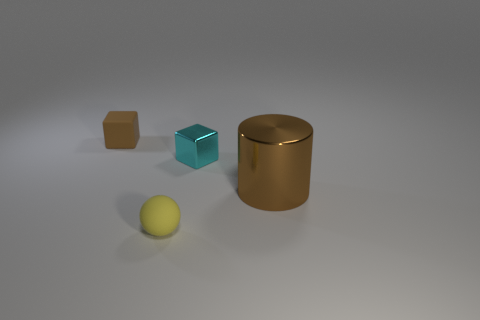What lighting conditions are depicted in the image? The lighting in the image seems to be soft and diffused, with subtle shadows, indicating an indirect light source that could be artificial, as seen in a studio setting. How does the lighting affect the mood of the image? The soft lighting creates a calm and neutral mood, with no harsh contrasts or dramatic shadows, giving the image a serene and contemplative atmosphere. 